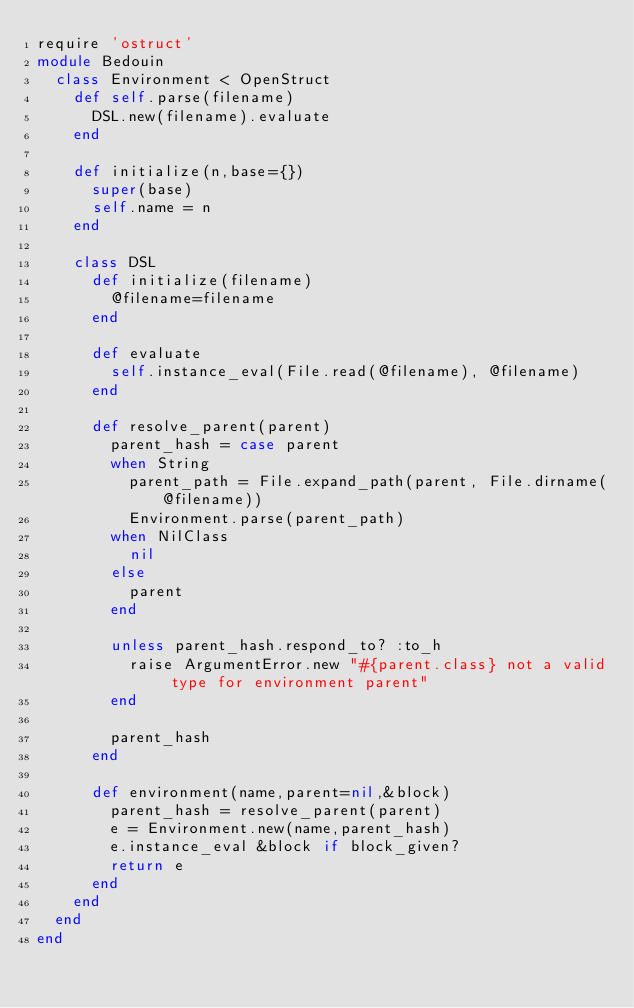<code> <loc_0><loc_0><loc_500><loc_500><_Ruby_>require 'ostruct'
module Bedouin
  class Environment < OpenStruct
    def self.parse(filename)
      DSL.new(filename).evaluate
    end

    def initialize(n,base={})
      super(base)
      self.name = n
    end

    class DSL
      def initialize(filename)
        @filename=filename
      end

      def evaluate
        self.instance_eval(File.read(@filename), @filename)
      end

      def resolve_parent(parent)
        parent_hash = case parent
        when String
          parent_path = File.expand_path(parent, File.dirname(@filename))
          Environment.parse(parent_path)
        when NilClass
          nil
        else
          parent
        end

        unless parent_hash.respond_to? :to_h
          raise ArgumentError.new "#{parent.class} not a valid type for environment parent"
        end

        parent_hash
      end

      def environment(name,parent=nil,&block)
        parent_hash = resolve_parent(parent)
        e = Environment.new(name,parent_hash)
        e.instance_eval &block if block_given?
        return e
      end
    end
  end
end
</code> 